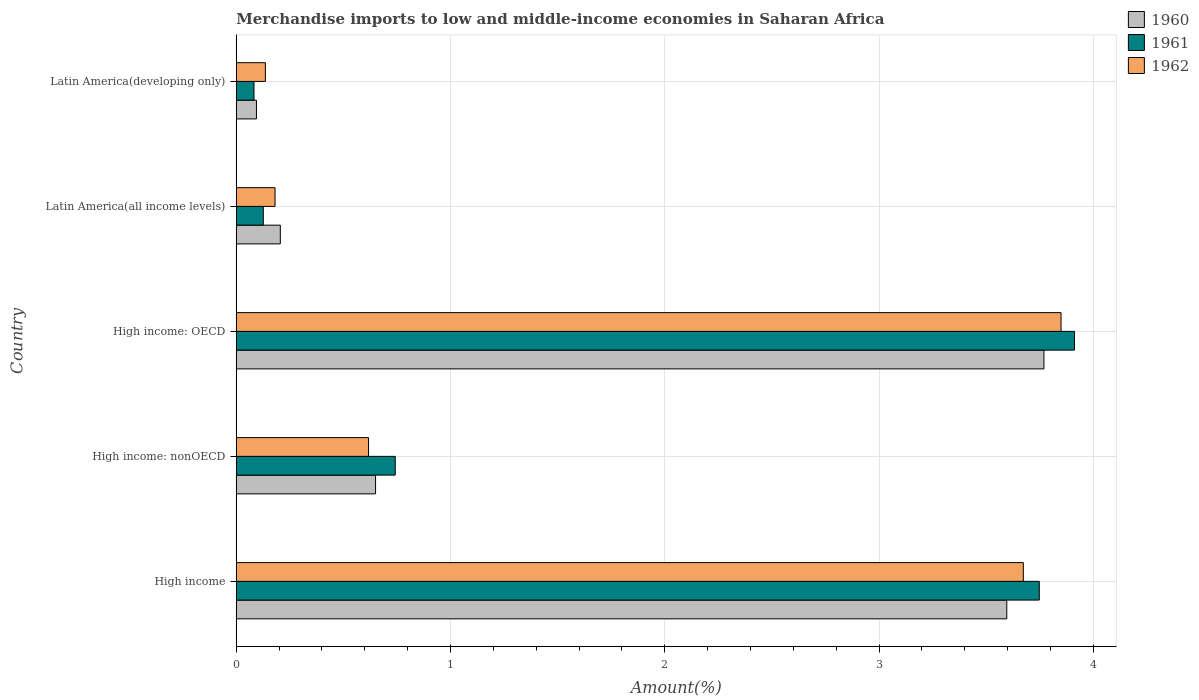How many different coloured bars are there?
Provide a short and direct response. 3. How many groups of bars are there?
Provide a succinct answer. 5. How many bars are there on the 3rd tick from the bottom?
Give a very brief answer. 3. In how many cases, is the number of bars for a given country not equal to the number of legend labels?
Your answer should be compact. 0. What is the percentage of amount earned from merchandise imports in 1961 in Latin America(all income levels)?
Your answer should be compact. 0.13. Across all countries, what is the maximum percentage of amount earned from merchandise imports in 1960?
Keep it short and to the point. 3.77. Across all countries, what is the minimum percentage of amount earned from merchandise imports in 1961?
Provide a succinct answer. 0.08. In which country was the percentage of amount earned from merchandise imports in 1962 maximum?
Offer a very short reply. High income: OECD. In which country was the percentage of amount earned from merchandise imports in 1960 minimum?
Offer a terse response. Latin America(developing only). What is the total percentage of amount earned from merchandise imports in 1961 in the graph?
Make the answer very short. 8.61. What is the difference between the percentage of amount earned from merchandise imports in 1962 in High income: nonOECD and that in Latin America(all income levels)?
Your response must be concise. 0.44. What is the difference between the percentage of amount earned from merchandise imports in 1961 in Latin America(developing only) and the percentage of amount earned from merchandise imports in 1962 in High income: nonOECD?
Give a very brief answer. -0.53. What is the average percentage of amount earned from merchandise imports in 1962 per country?
Ensure brevity in your answer.  1.69. What is the difference between the percentage of amount earned from merchandise imports in 1960 and percentage of amount earned from merchandise imports in 1962 in High income?
Give a very brief answer. -0.08. In how many countries, is the percentage of amount earned from merchandise imports in 1960 greater than 3.2 %?
Give a very brief answer. 2. What is the ratio of the percentage of amount earned from merchandise imports in 1962 in High income: nonOECD to that in Latin America(all income levels)?
Keep it short and to the point. 3.41. Is the difference between the percentage of amount earned from merchandise imports in 1960 in High income and Latin America(developing only) greater than the difference between the percentage of amount earned from merchandise imports in 1962 in High income and Latin America(developing only)?
Your response must be concise. No. What is the difference between the highest and the second highest percentage of amount earned from merchandise imports in 1962?
Give a very brief answer. 0.18. What is the difference between the highest and the lowest percentage of amount earned from merchandise imports in 1960?
Provide a succinct answer. 3.68. What does the 1st bar from the top in High income: OECD represents?
Your response must be concise. 1962. How many bars are there?
Ensure brevity in your answer.  15. Are all the bars in the graph horizontal?
Make the answer very short. Yes. How many countries are there in the graph?
Make the answer very short. 5. What is the difference between two consecutive major ticks on the X-axis?
Give a very brief answer. 1. Are the values on the major ticks of X-axis written in scientific E-notation?
Your response must be concise. No. Where does the legend appear in the graph?
Provide a succinct answer. Top right. How many legend labels are there?
Make the answer very short. 3. How are the legend labels stacked?
Your answer should be compact. Vertical. What is the title of the graph?
Offer a terse response. Merchandise imports to low and middle-income economies in Saharan Africa. What is the label or title of the X-axis?
Offer a very short reply. Amount(%). What is the Amount(%) in 1960 in High income?
Offer a terse response. 3.6. What is the Amount(%) of 1961 in High income?
Your answer should be very brief. 3.75. What is the Amount(%) of 1962 in High income?
Offer a very short reply. 3.67. What is the Amount(%) in 1960 in High income: nonOECD?
Provide a succinct answer. 0.65. What is the Amount(%) of 1961 in High income: nonOECD?
Ensure brevity in your answer.  0.74. What is the Amount(%) in 1962 in High income: nonOECD?
Keep it short and to the point. 0.62. What is the Amount(%) in 1960 in High income: OECD?
Your answer should be compact. 3.77. What is the Amount(%) of 1961 in High income: OECD?
Offer a terse response. 3.91. What is the Amount(%) in 1962 in High income: OECD?
Provide a short and direct response. 3.85. What is the Amount(%) in 1960 in Latin America(all income levels)?
Your answer should be compact. 0.21. What is the Amount(%) in 1961 in Latin America(all income levels)?
Provide a short and direct response. 0.13. What is the Amount(%) of 1962 in Latin America(all income levels)?
Your answer should be compact. 0.18. What is the Amount(%) in 1960 in Latin America(developing only)?
Provide a succinct answer. 0.09. What is the Amount(%) in 1961 in Latin America(developing only)?
Keep it short and to the point. 0.08. What is the Amount(%) in 1962 in Latin America(developing only)?
Your response must be concise. 0.14. Across all countries, what is the maximum Amount(%) of 1960?
Provide a short and direct response. 3.77. Across all countries, what is the maximum Amount(%) in 1961?
Make the answer very short. 3.91. Across all countries, what is the maximum Amount(%) in 1962?
Offer a terse response. 3.85. Across all countries, what is the minimum Amount(%) in 1960?
Provide a succinct answer. 0.09. Across all countries, what is the minimum Amount(%) in 1961?
Provide a succinct answer. 0.08. Across all countries, what is the minimum Amount(%) of 1962?
Give a very brief answer. 0.14. What is the total Amount(%) in 1960 in the graph?
Keep it short and to the point. 8.32. What is the total Amount(%) in 1961 in the graph?
Your response must be concise. 8.61. What is the total Amount(%) in 1962 in the graph?
Make the answer very short. 8.46. What is the difference between the Amount(%) of 1960 in High income and that in High income: nonOECD?
Provide a succinct answer. 2.95. What is the difference between the Amount(%) of 1961 in High income and that in High income: nonOECD?
Provide a short and direct response. 3.01. What is the difference between the Amount(%) of 1962 in High income and that in High income: nonOECD?
Keep it short and to the point. 3.06. What is the difference between the Amount(%) in 1960 in High income and that in High income: OECD?
Offer a very short reply. -0.17. What is the difference between the Amount(%) of 1961 in High income and that in High income: OECD?
Make the answer very short. -0.16. What is the difference between the Amount(%) of 1962 in High income and that in High income: OECD?
Ensure brevity in your answer.  -0.18. What is the difference between the Amount(%) of 1960 in High income and that in Latin America(all income levels)?
Your answer should be compact. 3.39. What is the difference between the Amount(%) of 1961 in High income and that in Latin America(all income levels)?
Offer a terse response. 3.62. What is the difference between the Amount(%) of 1962 in High income and that in Latin America(all income levels)?
Provide a succinct answer. 3.49. What is the difference between the Amount(%) of 1960 in High income and that in Latin America(developing only)?
Ensure brevity in your answer.  3.5. What is the difference between the Amount(%) of 1961 in High income and that in Latin America(developing only)?
Offer a very short reply. 3.66. What is the difference between the Amount(%) of 1962 in High income and that in Latin America(developing only)?
Provide a short and direct response. 3.54. What is the difference between the Amount(%) in 1960 in High income: nonOECD and that in High income: OECD?
Make the answer very short. -3.12. What is the difference between the Amount(%) of 1961 in High income: nonOECD and that in High income: OECD?
Your answer should be very brief. -3.17. What is the difference between the Amount(%) in 1962 in High income: nonOECD and that in High income: OECD?
Offer a terse response. -3.23. What is the difference between the Amount(%) in 1960 in High income: nonOECD and that in Latin America(all income levels)?
Keep it short and to the point. 0.44. What is the difference between the Amount(%) in 1961 in High income: nonOECD and that in Latin America(all income levels)?
Your answer should be compact. 0.62. What is the difference between the Amount(%) in 1962 in High income: nonOECD and that in Latin America(all income levels)?
Your answer should be very brief. 0.44. What is the difference between the Amount(%) in 1960 in High income: nonOECD and that in Latin America(developing only)?
Offer a very short reply. 0.56. What is the difference between the Amount(%) of 1961 in High income: nonOECD and that in Latin America(developing only)?
Your answer should be very brief. 0.66. What is the difference between the Amount(%) of 1962 in High income: nonOECD and that in Latin America(developing only)?
Your answer should be compact. 0.48. What is the difference between the Amount(%) of 1960 in High income: OECD and that in Latin America(all income levels)?
Provide a succinct answer. 3.56. What is the difference between the Amount(%) in 1961 in High income: OECD and that in Latin America(all income levels)?
Provide a succinct answer. 3.79. What is the difference between the Amount(%) in 1962 in High income: OECD and that in Latin America(all income levels)?
Provide a short and direct response. 3.67. What is the difference between the Amount(%) of 1960 in High income: OECD and that in Latin America(developing only)?
Provide a succinct answer. 3.68. What is the difference between the Amount(%) of 1961 in High income: OECD and that in Latin America(developing only)?
Your answer should be very brief. 3.83. What is the difference between the Amount(%) in 1962 in High income: OECD and that in Latin America(developing only)?
Offer a very short reply. 3.71. What is the difference between the Amount(%) of 1960 in Latin America(all income levels) and that in Latin America(developing only)?
Provide a succinct answer. 0.11. What is the difference between the Amount(%) of 1961 in Latin America(all income levels) and that in Latin America(developing only)?
Keep it short and to the point. 0.04. What is the difference between the Amount(%) of 1962 in Latin America(all income levels) and that in Latin America(developing only)?
Keep it short and to the point. 0.05. What is the difference between the Amount(%) in 1960 in High income and the Amount(%) in 1961 in High income: nonOECD?
Give a very brief answer. 2.85. What is the difference between the Amount(%) of 1960 in High income and the Amount(%) of 1962 in High income: nonOECD?
Make the answer very short. 2.98. What is the difference between the Amount(%) in 1961 in High income and the Amount(%) in 1962 in High income: nonOECD?
Keep it short and to the point. 3.13. What is the difference between the Amount(%) of 1960 in High income and the Amount(%) of 1961 in High income: OECD?
Make the answer very short. -0.32. What is the difference between the Amount(%) of 1960 in High income and the Amount(%) of 1962 in High income: OECD?
Ensure brevity in your answer.  -0.25. What is the difference between the Amount(%) in 1961 in High income and the Amount(%) in 1962 in High income: OECD?
Give a very brief answer. -0.1. What is the difference between the Amount(%) of 1960 in High income and the Amount(%) of 1961 in Latin America(all income levels)?
Provide a succinct answer. 3.47. What is the difference between the Amount(%) in 1960 in High income and the Amount(%) in 1962 in Latin America(all income levels)?
Provide a succinct answer. 3.41. What is the difference between the Amount(%) of 1961 in High income and the Amount(%) of 1962 in Latin America(all income levels)?
Offer a terse response. 3.57. What is the difference between the Amount(%) in 1960 in High income and the Amount(%) in 1961 in Latin America(developing only)?
Keep it short and to the point. 3.51. What is the difference between the Amount(%) of 1960 in High income and the Amount(%) of 1962 in Latin America(developing only)?
Offer a very short reply. 3.46. What is the difference between the Amount(%) of 1961 in High income and the Amount(%) of 1962 in Latin America(developing only)?
Offer a terse response. 3.61. What is the difference between the Amount(%) in 1960 in High income: nonOECD and the Amount(%) in 1961 in High income: OECD?
Your answer should be compact. -3.26. What is the difference between the Amount(%) in 1960 in High income: nonOECD and the Amount(%) in 1962 in High income: OECD?
Offer a terse response. -3.2. What is the difference between the Amount(%) in 1961 in High income: nonOECD and the Amount(%) in 1962 in High income: OECD?
Your response must be concise. -3.11. What is the difference between the Amount(%) of 1960 in High income: nonOECD and the Amount(%) of 1961 in Latin America(all income levels)?
Your response must be concise. 0.52. What is the difference between the Amount(%) in 1960 in High income: nonOECD and the Amount(%) in 1962 in Latin America(all income levels)?
Ensure brevity in your answer.  0.47. What is the difference between the Amount(%) of 1961 in High income: nonOECD and the Amount(%) of 1962 in Latin America(all income levels)?
Your answer should be very brief. 0.56. What is the difference between the Amount(%) of 1960 in High income: nonOECD and the Amount(%) of 1961 in Latin America(developing only)?
Give a very brief answer. 0.57. What is the difference between the Amount(%) of 1960 in High income: nonOECD and the Amount(%) of 1962 in Latin America(developing only)?
Offer a terse response. 0.51. What is the difference between the Amount(%) of 1961 in High income: nonOECD and the Amount(%) of 1962 in Latin America(developing only)?
Your response must be concise. 0.61. What is the difference between the Amount(%) in 1960 in High income: OECD and the Amount(%) in 1961 in Latin America(all income levels)?
Ensure brevity in your answer.  3.64. What is the difference between the Amount(%) in 1960 in High income: OECD and the Amount(%) in 1962 in Latin America(all income levels)?
Your answer should be very brief. 3.59. What is the difference between the Amount(%) in 1961 in High income: OECD and the Amount(%) in 1962 in Latin America(all income levels)?
Offer a terse response. 3.73. What is the difference between the Amount(%) of 1960 in High income: OECD and the Amount(%) of 1961 in Latin America(developing only)?
Ensure brevity in your answer.  3.69. What is the difference between the Amount(%) in 1960 in High income: OECD and the Amount(%) in 1962 in Latin America(developing only)?
Give a very brief answer. 3.63. What is the difference between the Amount(%) in 1961 in High income: OECD and the Amount(%) in 1962 in Latin America(developing only)?
Provide a succinct answer. 3.78. What is the difference between the Amount(%) of 1960 in Latin America(all income levels) and the Amount(%) of 1961 in Latin America(developing only)?
Keep it short and to the point. 0.12. What is the difference between the Amount(%) in 1960 in Latin America(all income levels) and the Amount(%) in 1962 in Latin America(developing only)?
Provide a succinct answer. 0.07. What is the difference between the Amount(%) of 1961 in Latin America(all income levels) and the Amount(%) of 1962 in Latin America(developing only)?
Your answer should be very brief. -0.01. What is the average Amount(%) of 1960 per country?
Ensure brevity in your answer.  1.66. What is the average Amount(%) in 1961 per country?
Your answer should be compact. 1.72. What is the average Amount(%) of 1962 per country?
Offer a very short reply. 1.69. What is the difference between the Amount(%) in 1960 and Amount(%) in 1961 in High income?
Give a very brief answer. -0.15. What is the difference between the Amount(%) of 1960 and Amount(%) of 1962 in High income?
Your answer should be very brief. -0.08. What is the difference between the Amount(%) in 1961 and Amount(%) in 1962 in High income?
Keep it short and to the point. 0.07. What is the difference between the Amount(%) in 1960 and Amount(%) in 1961 in High income: nonOECD?
Provide a succinct answer. -0.09. What is the difference between the Amount(%) of 1960 and Amount(%) of 1962 in High income: nonOECD?
Your answer should be compact. 0.03. What is the difference between the Amount(%) in 1961 and Amount(%) in 1962 in High income: nonOECD?
Your response must be concise. 0.12. What is the difference between the Amount(%) in 1960 and Amount(%) in 1961 in High income: OECD?
Offer a terse response. -0.14. What is the difference between the Amount(%) in 1960 and Amount(%) in 1962 in High income: OECD?
Provide a succinct answer. -0.08. What is the difference between the Amount(%) of 1961 and Amount(%) of 1962 in High income: OECD?
Offer a terse response. 0.06. What is the difference between the Amount(%) of 1960 and Amount(%) of 1961 in Latin America(all income levels)?
Your answer should be very brief. 0.08. What is the difference between the Amount(%) in 1960 and Amount(%) in 1962 in Latin America(all income levels)?
Offer a terse response. 0.02. What is the difference between the Amount(%) in 1961 and Amount(%) in 1962 in Latin America(all income levels)?
Ensure brevity in your answer.  -0.05. What is the difference between the Amount(%) in 1960 and Amount(%) in 1961 in Latin America(developing only)?
Your answer should be very brief. 0.01. What is the difference between the Amount(%) of 1960 and Amount(%) of 1962 in Latin America(developing only)?
Give a very brief answer. -0.04. What is the difference between the Amount(%) in 1961 and Amount(%) in 1962 in Latin America(developing only)?
Your answer should be compact. -0.05. What is the ratio of the Amount(%) of 1960 in High income to that in High income: nonOECD?
Your answer should be very brief. 5.53. What is the ratio of the Amount(%) of 1961 in High income to that in High income: nonOECD?
Your response must be concise. 5.05. What is the ratio of the Amount(%) in 1962 in High income to that in High income: nonOECD?
Your answer should be compact. 5.95. What is the ratio of the Amount(%) in 1960 in High income to that in High income: OECD?
Your answer should be compact. 0.95. What is the ratio of the Amount(%) in 1961 in High income to that in High income: OECD?
Keep it short and to the point. 0.96. What is the ratio of the Amount(%) of 1962 in High income to that in High income: OECD?
Offer a terse response. 0.95. What is the ratio of the Amount(%) in 1960 in High income to that in Latin America(all income levels)?
Provide a succinct answer. 17.49. What is the ratio of the Amount(%) of 1961 in High income to that in Latin America(all income levels)?
Offer a terse response. 29.69. What is the ratio of the Amount(%) of 1962 in High income to that in Latin America(all income levels)?
Offer a very short reply. 20.29. What is the ratio of the Amount(%) in 1960 in High income to that in Latin America(developing only)?
Provide a succinct answer. 38.16. What is the ratio of the Amount(%) of 1961 in High income to that in Latin America(developing only)?
Offer a very short reply. 45.28. What is the ratio of the Amount(%) of 1962 in High income to that in Latin America(developing only)?
Offer a terse response. 27.01. What is the ratio of the Amount(%) of 1960 in High income: nonOECD to that in High income: OECD?
Offer a terse response. 0.17. What is the ratio of the Amount(%) in 1961 in High income: nonOECD to that in High income: OECD?
Offer a terse response. 0.19. What is the ratio of the Amount(%) in 1962 in High income: nonOECD to that in High income: OECD?
Provide a short and direct response. 0.16. What is the ratio of the Amount(%) in 1960 in High income: nonOECD to that in Latin America(all income levels)?
Your response must be concise. 3.16. What is the ratio of the Amount(%) of 1961 in High income: nonOECD to that in Latin America(all income levels)?
Your answer should be compact. 5.88. What is the ratio of the Amount(%) of 1962 in High income: nonOECD to that in Latin America(all income levels)?
Keep it short and to the point. 3.41. What is the ratio of the Amount(%) of 1960 in High income: nonOECD to that in Latin America(developing only)?
Give a very brief answer. 6.9. What is the ratio of the Amount(%) in 1961 in High income: nonOECD to that in Latin America(developing only)?
Give a very brief answer. 8.96. What is the ratio of the Amount(%) of 1962 in High income: nonOECD to that in Latin America(developing only)?
Give a very brief answer. 4.54. What is the ratio of the Amount(%) in 1960 in High income: OECD to that in Latin America(all income levels)?
Provide a short and direct response. 18.33. What is the ratio of the Amount(%) of 1961 in High income: OECD to that in Latin America(all income levels)?
Offer a terse response. 30.99. What is the ratio of the Amount(%) of 1962 in High income: OECD to that in Latin America(all income levels)?
Give a very brief answer. 21.26. What is the ratio of the Amount(%) of 1960 in High income: OECD to that in Latin America(developing only)?
Keep it short and to the point. 40. What is the ratio of the Amount(%) of 1961 in High income: OECD to that in Latin America(developing only)?
Your answer should be compact. 47.27. What is the ratio of the Amount(%) in 1962 in High income: OECD to that in Latin America(developing only)?
Make the answer very short. 28.31. What is the ratio of the Amount(%) in 1960 in Latin America(all income levels) to that in Latin America(developing only)?
Keep it short and to the point. 2.18. What is the ratio of the Amount(%) in 1961 in Latin America(all income levels) to that in Latin America(developing only)?
Keep it short and to the point. 1.53. What is the ratio of the Amount(%) in 1962 in Latin America(all income levels) to that in Latin America(developing only)?
Your answer should be very brief. 1.33. What is the difference between the highest and the second highest Amount(%) in 1960?
Make the answer very short. 0.17. What is the difference between the highest and the second highest Amount(%) of 1961?
Your answer should be compact. 0.16. What is the difference between the highest and the second highest Amount(%) in 1962?
Your answer should be very brief. 0.18. What is the difference between the highest and the lowest Amount(%) of 1960?
Offer a terse response. 3.68. What is the difference between the highest and the lowest Amount(%) of 1961?
Give a very brief answer. 3.83. What is the difference between the highest and the lowest Amount(%) of 1962?
Provide a succinct answer. 3.71. 